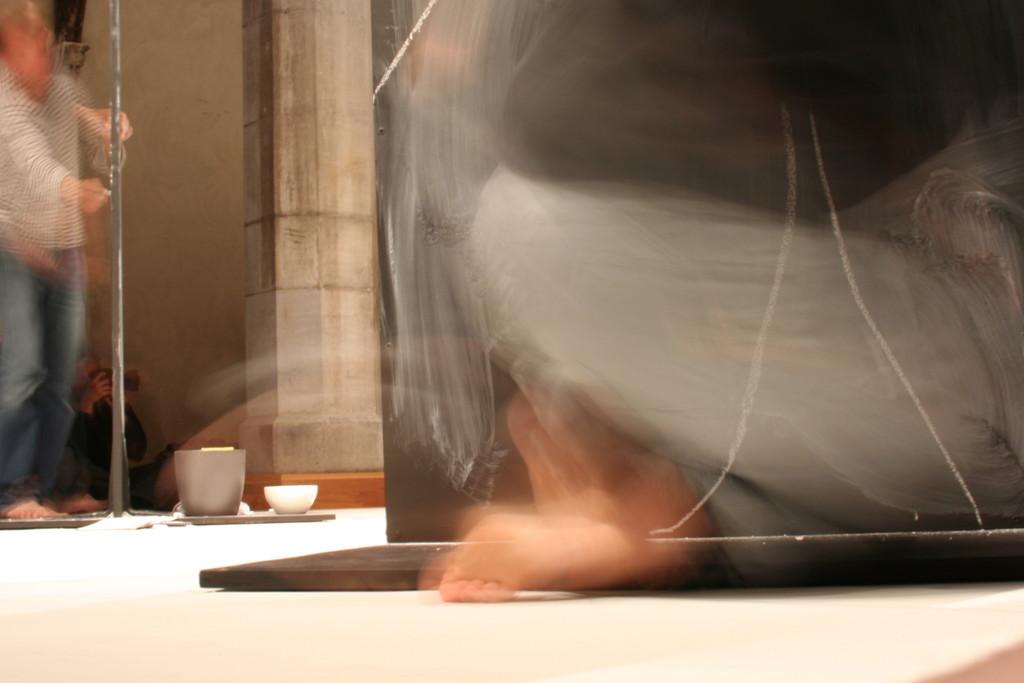Who or what can be seen in the image? There are people in the image. What objects are present in the image? There is a bowl and a mug in the image. What architectural feature is visible in the image? There is a pillar in the image. What part of the setting is visible at the bottom of the image? The floor is visible at the bottom of the image. How many snakes are wrapped around the pillar in the image? There are no snakes present in the image; it only features people, a bowl, a mug, a pillar, and the floor. 